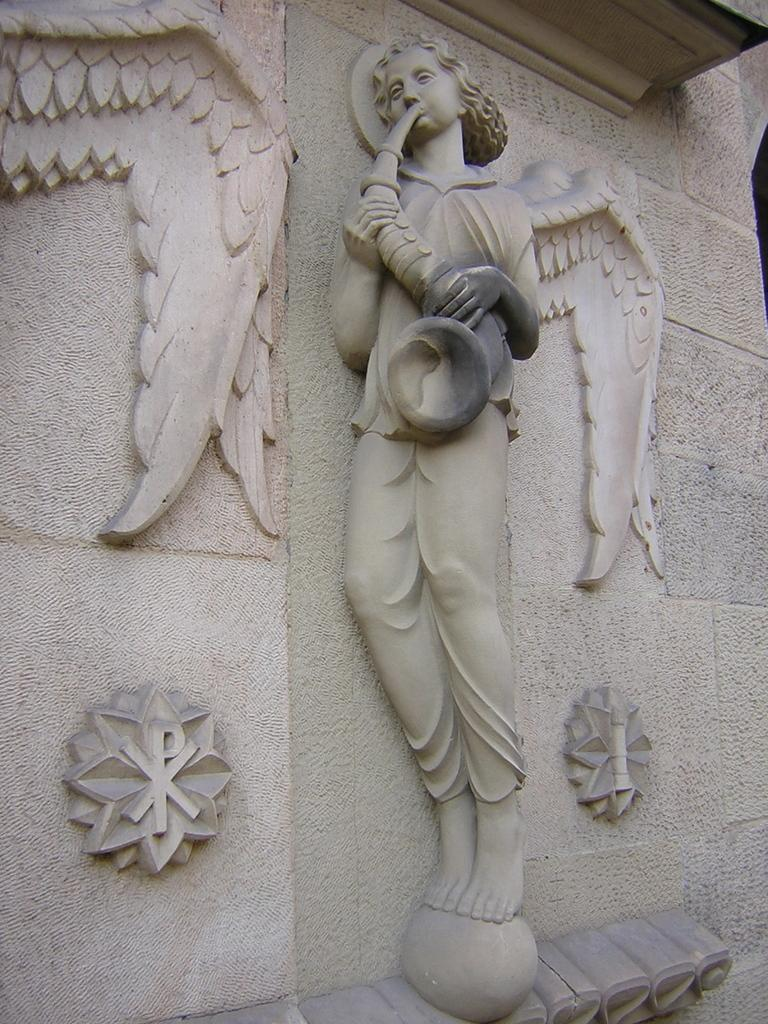What is on the wall in the image? There is a sculpture on the wall in the image. How much does the sponge weigh in the image? There is no sponge present in the image, so it is not possible to determine its weight. 